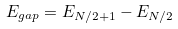<formula> <loc_0><loc_0><loc_500><loc_500>E _ { g a p } = E _ { N / 2 + 1 } - E _ { N / 2 }</formula> 